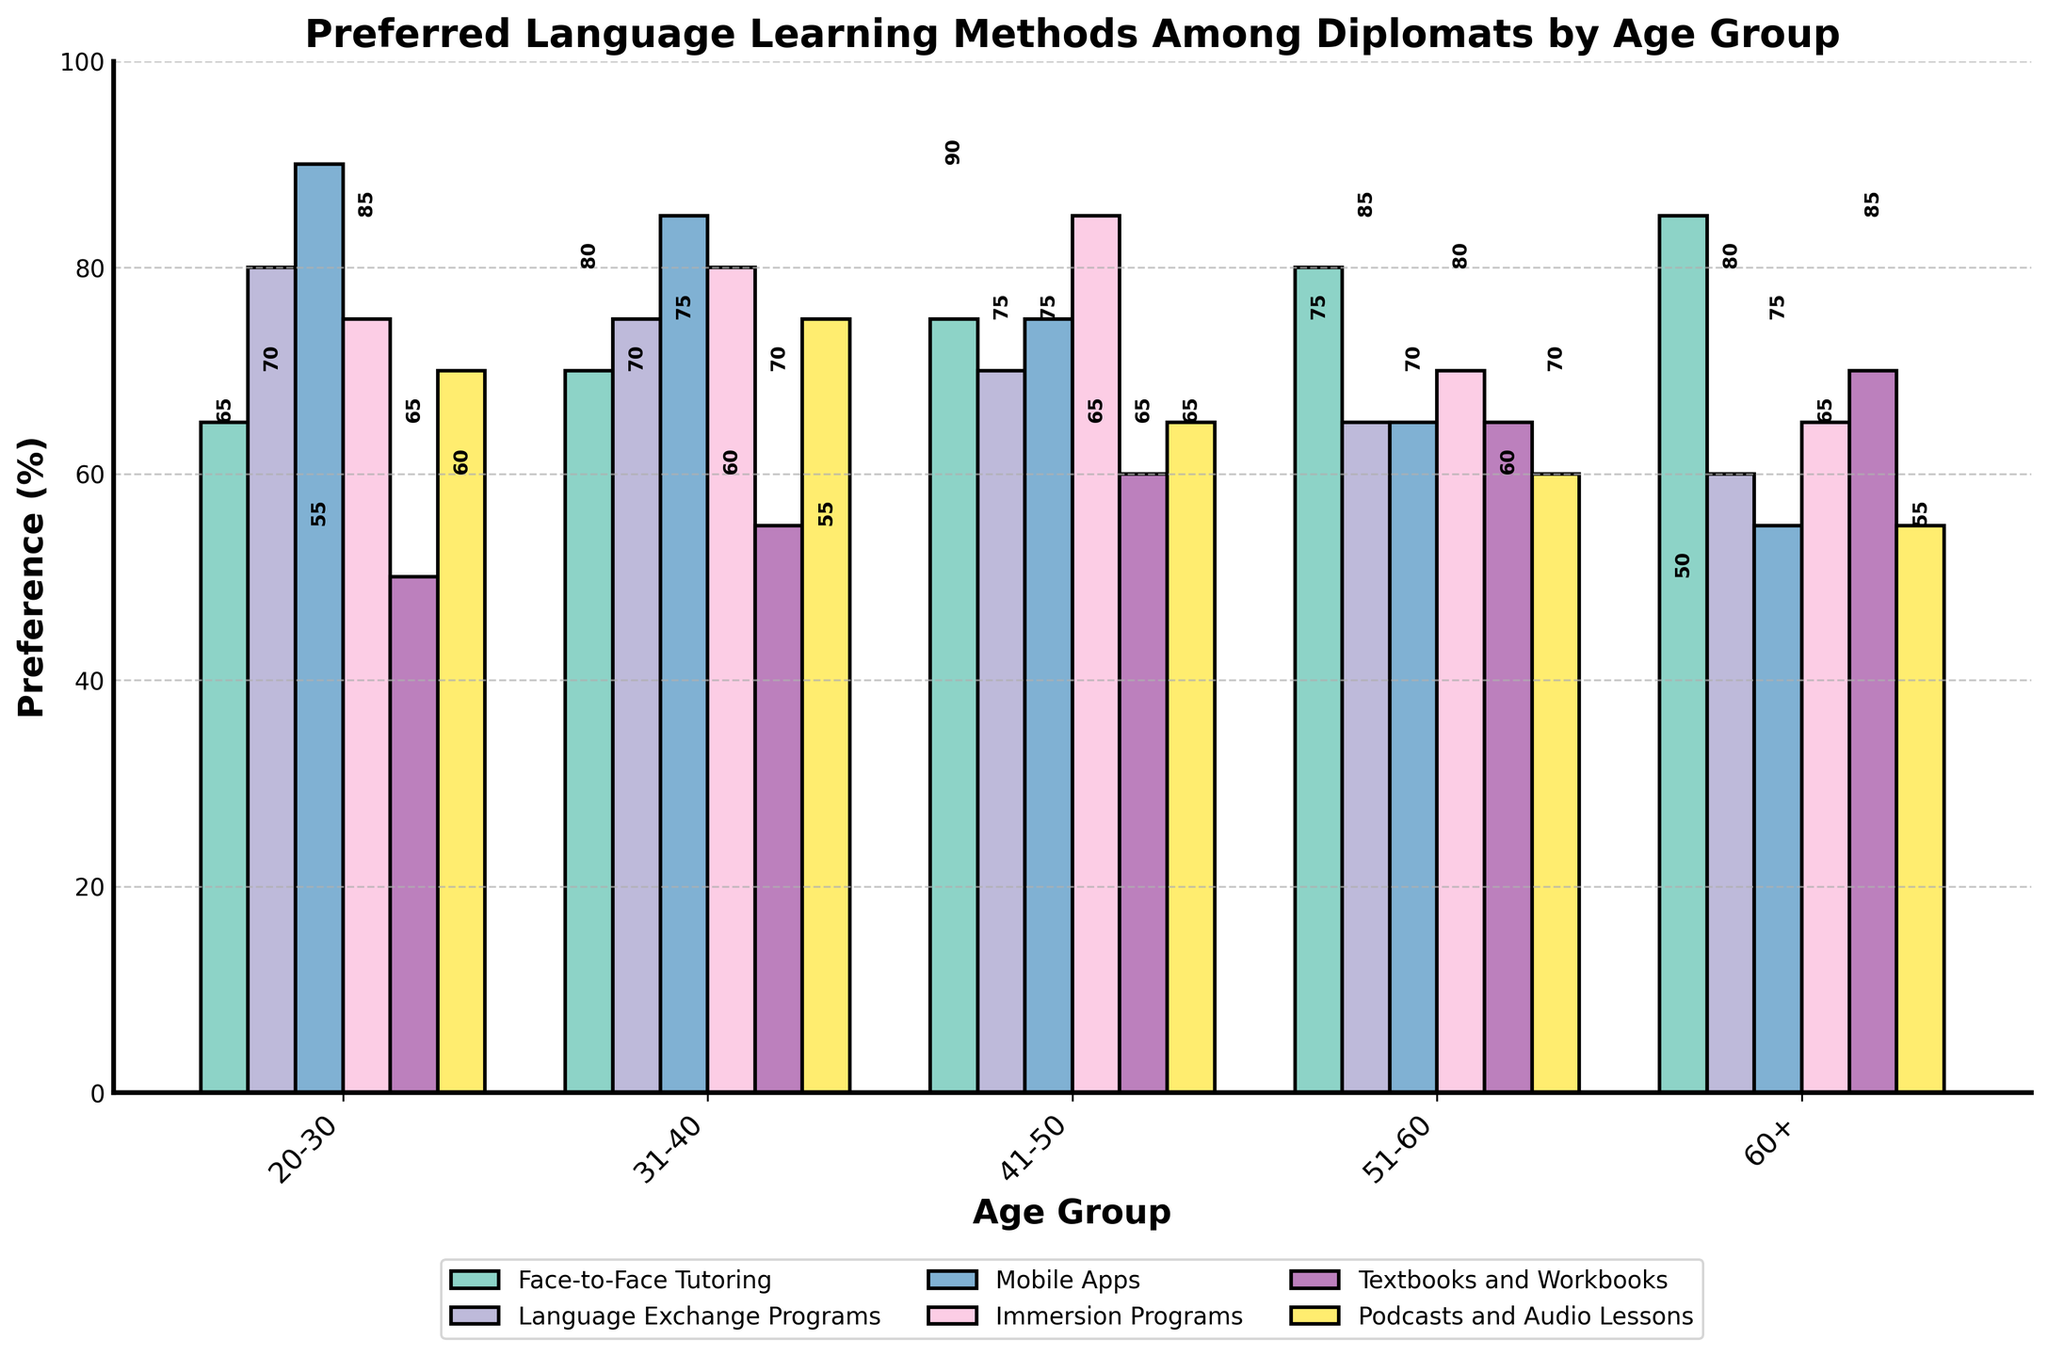Which age group shows the highest preference for Face-to-Face Tutoring? The bar for the 60+ age group reaches the highest percentage at 85%. Visual comparison with other age groups confirms this.
Answer: 60+ Which age group has the lowest preference for Mobile Apps? Looking at the height of the bars under 'Mobile Apps,' the 60+ age group has the smallest bar at 55%.
Answer: 60+ How does the preference for Immersion Programs differ between the 41-50 and 51-60 age groups? For the 41-50 age group, the bar height is at 85%, whereas for the 51-60 age group, it is at 70%. The difference is 85% - 70% = 15%.
Answer: 15% Which method is consistently preferred less by older age groups (51-60 and 60+)? By examining the bar heights for both 51-60 and 60+ age groups, Mobile Apps (65% and 55%) show a decreasing trend compared to other methods.
Answer: Mobile Apps What is the average preference for Podcasts and Audio Lessons across all age groups? The percentages for Podcasts and Audio Lessons are 70%, 75%, 65%, 60%, and 55%. Sum these values (70+75+65+60+55) = 325 and divide by 5 (the number of age groups). The average is 325/5 = 65%.
Answer: 65 Which language learning method has the narrowest range of preferences across all age groups? Calculate the range (max - min) for each method. Face-to-Face Tutoring ranges from 65 to 85 (20), Language Exchange Programs from 60 to 80 (20), Mobile Apps from 55 to 90 (35), Immersion Programs from 65 to 85 (20), Textbooks and Workbooks from 50 to 70 (20), and Podcasts and Audio Lessons from 55 to 75 (20). All except Mobile Apps have the same narrowest range.
Answer: Face-to-Face Tutoring, Language Exchange Programs, Immersion Programs, Textbooks and Workbooks, Podcasts and Audio Lessons Between which two adjacent age groups is there the largest difference in preference for Textbooks and Workbooks? By comparing the adjacent age groups, the largest difference is between 51-60 (65%) and 60+ (70%), which is a difference of 70% - 65% = 5%.
Answer: 51-60 and 60+ What is the sum of preferences for Language Exchange Programs and Immersion Programs within the 31-40 age group? For the 31-40 age group, Language Exchange Programs have a value of 75% and Immersion Programs have 80%. Summing these values, 75 + 80 = 155%.
Answer: 155 Do older age groups (51-60 and 60+) show a higher preference for Textbooks and Workbooks compared to younger age groups (20-30)? Compare 51-60 (65%) and 60+ (70%) to 20-30 (50%). Both older groups show higher preferences.
Answer: Yes In the 20-30 age group, which method is most preferred and which is least preferred? The highest bar for the 20-30 age group is Mobile Apps at 90% and the lowest is Textbooks and Workbooks at 50%.
Answer: Most: Mobile Apps, Least: Textbooks and Workbooks 